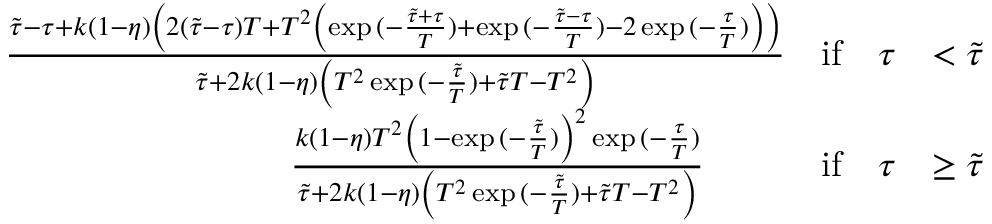Convert formula to latex. <formula><loc_0><loc_0><loc_500><loc_500>\begin{array} { r l r l } & { \frac { \tilde { \tau } - \tau + k ( 1 - \eta ) \left ( 2 ( \tilde { \tau } - \tau ) T + T ^ { 2 } \left ( \exp { ( - \frac { \tilde { \tau } + \tau } { T } ) } + \exp { ( - \frac { \tilde { \tau } - \tau } { T } ) } - 2 \exp { ( - \frac { \tau } { T } ) } \right ) \right ) } { \tilde { \tau } + 2 k ( 1 - \eta ) \left ( T ^ { 2 } \exp { ( - \frac { \tilde { \tau } } { T } ) } + \tilde { \tau } T - T ^ { 2 } \right ) } } & { i f \quad \tau } & { < \tilde { \tau } } \\ & { \quad \frac { k ( 1 - \eta ) T ^ { 2 } \left ( 1 - \exp { ( - \frac { \tilde { \tau } } { T } ) } \right ) ^ { 2 } \exp { ( - \frac { \tau } { T } ) } } { \tilde { \tau } + 2 k ( 1 - \eta ) \left ( T ^ { 2 } \exp { ( - \frac { \tilde { \tau } } { T } ) } + \tilde { \tau } T - T ^ { 2 } \right ) } } & { i f \quad \tau } & { \geq \tilde { \tau } } \end{array}</formula> 